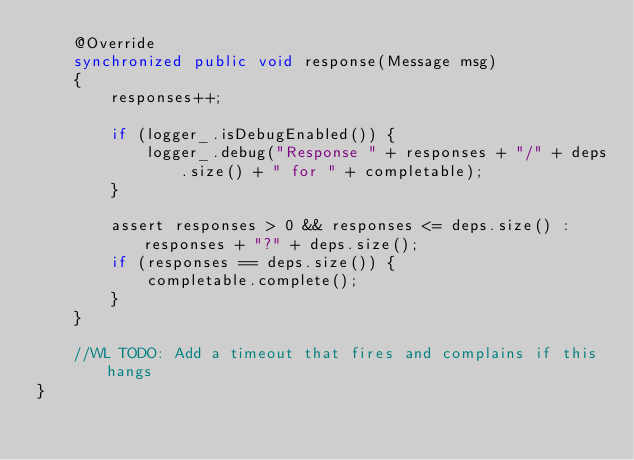<code> <loc_0><loc_0><loc_500><loc_500><_Java_>    @Override
    synchronized public void response(Message msg)
    {
        responses++;

        if (logger_.isDebugEnabled()) {
            logger_.debug("Response " + responses + "/" + deps.size() + " for " + completable);
        }

        assert responses > 0 && responses <= deps.size() : responses + "?" + deps.size();
        if (responses == deps.size()) {
            completable.complete();
        }
    }

    //WL TODO: Add a timeout that fires and complains if this hangs
}
</code> 